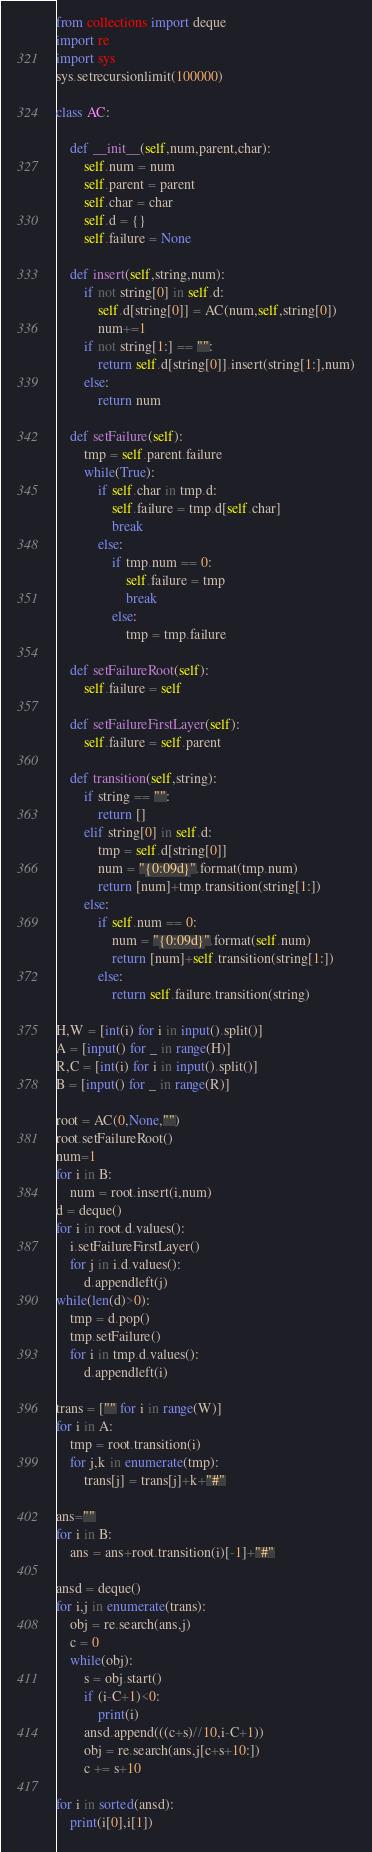<code> <loc_0><loc_0><loc_500><loc_500><_Python_>from collections import deque
import re
import sys
sys.setrecursionlimit(100000)

class AC:
    
    def __init__(self,num,parent,char):
        self.num = num
        self.parent = parent
        self.char = char
        self.d = {}
        self.failure = None
        
    def insert(self,string,num):
        if not string[0] in self.d:
            self.d[string[0]] = AC(num,self,string[0])
            num+=1
        if not string[1:] == "":
            return self.d[string[0]].insert(string[1:],num)
        else:
            return num
        
    def setFailure(self):
        tmp = self.parent.failure
        while(True):
            if self.char in tmp.d:
                self.failure = tmp.d[self.char]
                break
            else:
                if tmp.num == 0:
                    self.failure = tmp
                    break
                else:
                    tmp = tmp.failure
    
    def setFailureRoot(self):
        self.failure = self
    
    def setFailureFirstLayer(self):
        self.failure = self.parent
       
    def transition(self,string):
        if string == "":
            return []
        elif string[0] in self.d:
            tmp = self.d[string[0]]
            num = "{0:09d}".format(tmp.num) 
            return [num]+tmp.transition(string[1:])
        else:
            if self.num == 0:
                num = "{0:09d}".format(self.num)
                return [num]+self.transition(string[1:])
            else:
                return self.failure.transition(string)
    
H,W = [int(i) for i in input().split()]
A = [input() for _ in range(H)]
R,C = [int(i) for i in input().split()]
B = [input() for _ in range(R)]

root = AC(0,None,"")
root.setFailureRoot()
num=1
for i in B:
    num = root.insert(i,num)
d = deque()
for i in root.d.values():
    i.setFailureFirstLayer()
    for j in i.d.values():
        d.appendleft(j)
while(len(d)>0):
    tmp = d.pop()
    tmp.setFailure()
    for i in tmp.d.values():
        d.appendleft(i)
        
trans = ["" for i in range(W)]
for i in A:
    tmp = root.transition(i)
    for j,k in enumerate(tmp):
        trans[j] = trans[j]+k+"#"

ans=""
for i in B:
    ans = ans+root.transition(i)[-1]+"#"

ansd = deque()
for i,j in enumerate(trans):
    obj = re.search(ans,j)
    c = 0
    while(obj):
        s = obj.start()
        if (i-C+1)<0:
            print(i)
        ansd.append(((c+s)//10,i-C+1))
        obj = re.search(ans,j[c+s+10:])
        c += s+10

for i in sorted(ansd):
    print(i[0],i[1])
</code> 